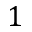Convert formula to latex. <formula><loc_0><loc_0><loc_500><loc_500>1</formula> 